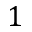Convert formula to latex. <formula><loc_0><loc_0><loc_500><loc_500>1</formula> 